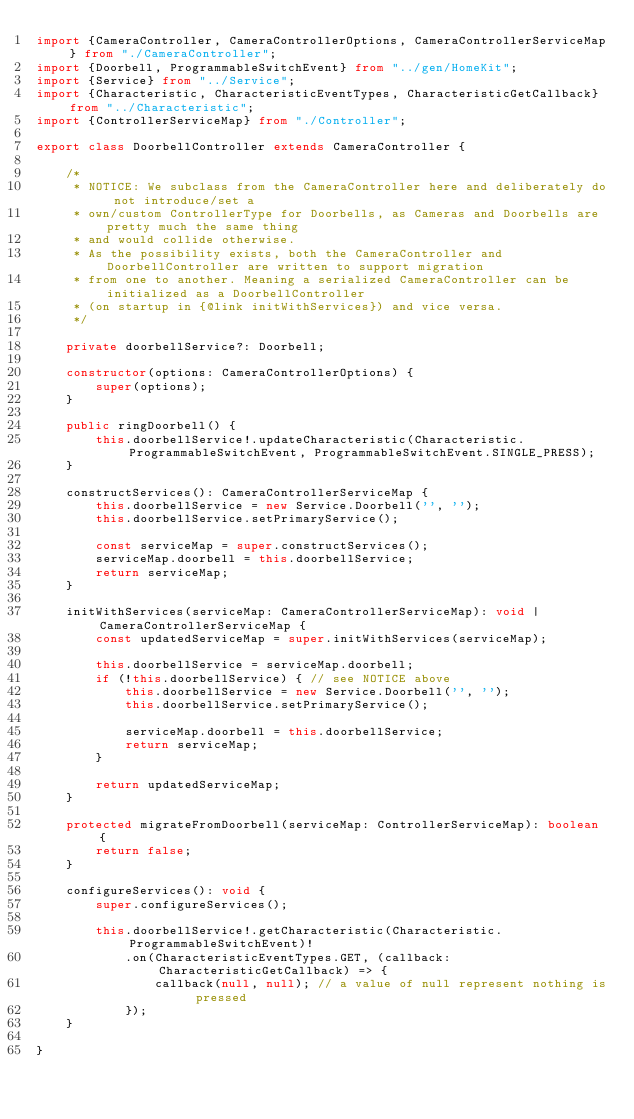<code> <loc_0><loc_0><loc_500><loc_500><_TypeScript_>import {CameraController, CameraControllerOptions, CameraControllerServiceMap} from "./CameraController";
import {Doorbell, ProgrammableSwitchEvent} from "../gen/HomeKit";
import {Service} from "../Service";
import {Characteristic, CharacteristicEventTypes, CharacteristicGetCallback} from "../Characteristic";
import {ControllerServiceMap} from "./Controller";

export class DoorbellController extends CameraController {

    /*
     * NOTICE: We subclass from the CameraController here and deliberately do not introduce/set a
     * own/custom ControllerType for Doorbells, as Cameras and Doorbells are pretty much the same thing
     * and would collide otherwise.
     * As the possibility exists, both the CameraController and DoorbellController are written to support migration
     * from one to another. Meaning a serialized CameraController can be initialized as a DoorbellController
     * (on startup in {@link initWithServices}) and vice versa.
     */

    private doorbellService?: Doorbell;

    constructor(options: CameraControllerOptions) {
        super(options);
    }

    public ringDoorbell() {
        this.doorbellService!.updateCharacteristic(Characteristic.ProgrammableSwitchEvent, ProgrammableSwitchEvent.SINGLE_PRESS);
    }

    constructServices(): CameraControllerServiceMap {
        this.doorbellService = new Service.Doorbell('', '');
        this.doorbellService.setPrimaryService();

        const serviceMap = super.constructServices();
        serviceMap.doorbell = this.doorbellService;
        return serviceMap;
    }

    initWithServices(serviceMap: CameraControllerServiceMap): void | CameraControllerServiceMap {
        const updatedServiceMap = super.initWithServices(serviceMap);

        this.doorbellService = serviceMap.doorbell;
        if (!this.doorbellService) { // see NOTICE above
            this.doorbellService = new Service.Doorbell('', '');
            this.doorbellService.setPrimaryService();

            serviceMap.doorbell = this.doorbellService;
            return serviceMap;
        }

        return updatedServiceMap;
    }

    protected migrateFromDoorbell(serviceMap: ControllerServiceMap): boolean {
        return false;
    }

    configureServices(): void {
        super.configureServices();

        this.doorbellService!.getCharacteristic(Characteristic.ProgrammableSwitchEvent)!
            .on(CharacteristicEventTypes.GET, (callback: CharacteristicGetCallback) => {
                callback(null, null); // a value of null represent nothing is pressed
            });
    }

}
</code> 